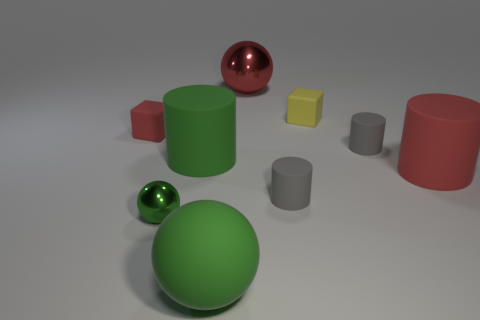Add 1 red balls. How many objects exist? 10 Subtract all cylinders. How many objects are left? 5 Add 9 brown metal cylinders. How many brown metal cylinders exist? 9 Subtract 1 red spheres. How many objects are left? 8 Subtract all red rubber cylinders. Subtract all tiny gray rubber objects. How many objects are left? 6 Add 4 big spheres. How many big spheres are left? 6 